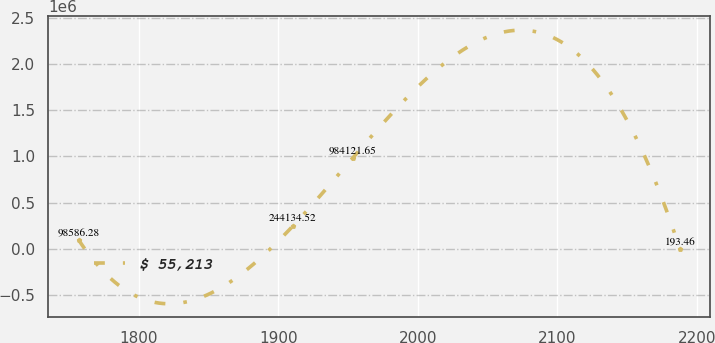Convert chart to OTSL. <chart><loc_0><loc_0><loc_500><loc_500><line_chart><ecel><fcel>$ 55,213<nl><fcel>1756.7<fcel>98586.3<nl><fcel>1910.23<fcel>244135<nl><fcel>1953.34<fcel>984122<nl><fcel>2187.82<fcel>193.46<nl></chart> 